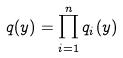Convert formula to latex. <formula><loc_0><loc_0><loc_500><loc_500>q ( y ) = \prod _ { i = 1 } ^ { n } q _ { i } ( y )</formula> 